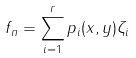Convert formula to latex. <formula><loc_0><loc_0><loc_500><loc_500>f _ { n } = \sum _ { i = 1 } ^ { r } p _ { i } ( x , y ) \zeta _ { i }</formula> 